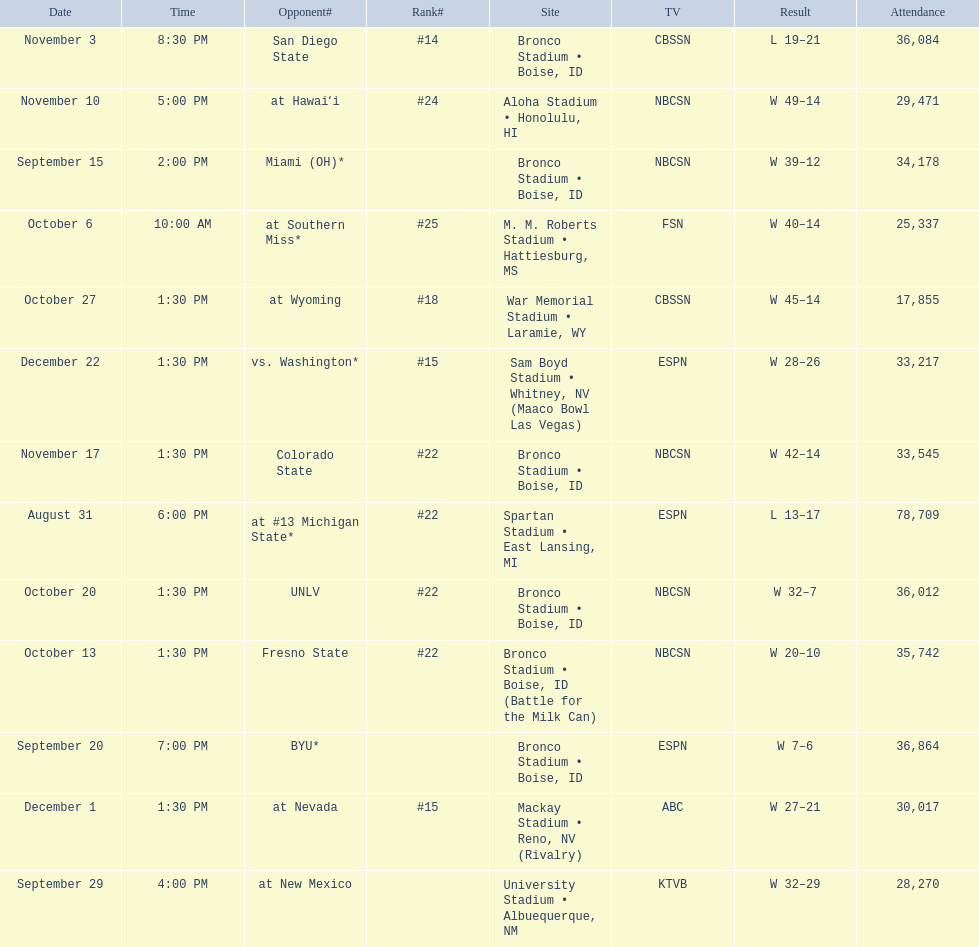Who were all of the opponents? At #13 michigan state*, miami (oh)*, byu*, at new mexico, at southern miss*, fresno state, unlv, at wyoming, san diego state, at hawaiʻi, colorado state, at nevada, vs. washington*. Who did they face on november 3rd? San Diego State. What rank were they on november 3rd? #14. 